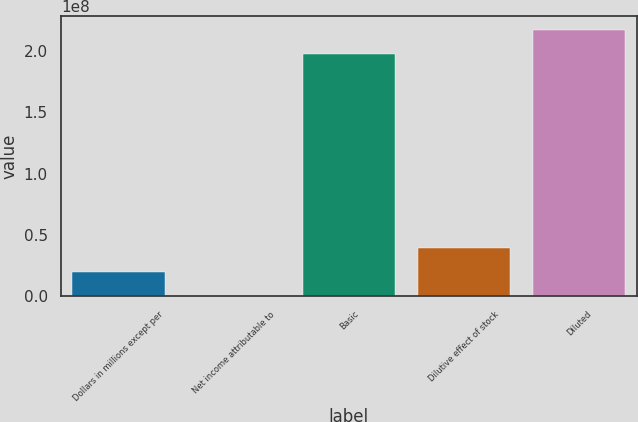Convert chart to OTSL. <chart><loc_0><loc_0><loc_500><loc_500><bar_chart><fcel>Dollars in millions except per<fcel>Net income attributable to<fcel>Basic<fcel>Dilutive effect of stock<fcel>Diluted<nl><fcel>1.97699e+07<fcel>428<fcel>1.97446e+08<fcel>3.95394e+07<fcel>2.17215e+08<nl></chart> 